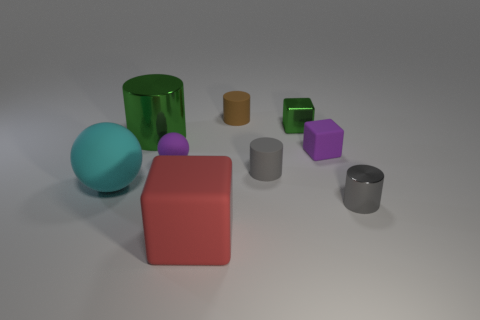Subtract 1 cubes. How many cubes are left? 2 Subtract all brown cylinders. How many cylinders are left? 3 Subtract all yellow cylinders. Subtract all purple spheres. How many cylinders are left? 4 Add 1 tiny green rubber spheres. How many objects exist? 10 Subtract all cylinders. How many objects are left? 5 Subtract 0 purple cylinders. How many objects are left? 9 Subtract all gray shiny cylinders. Subtract all tiny purple matte blocks. How many objects are left? 7 Add 5 brown objects. How many brown objects are left? 6 Add 7 green metallic cubes. How many green metallic cubes exist? 8 